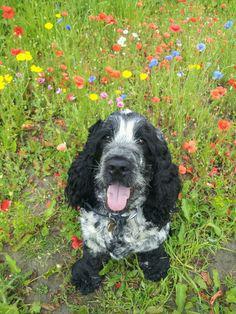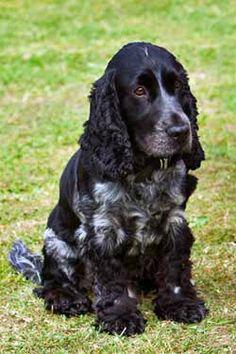The first image is the image on the left, the second image is the image on the right. Analyze the images presented: Is the assertion "The dog on the left has its tongue out." valid? Answer yes or no. Yes. The first image is the image on the left, the second image is the image on the right. For the images shown, is this caption "One dog is sitting with its tongue hanging out." true? Answer yes or no. Yes. 